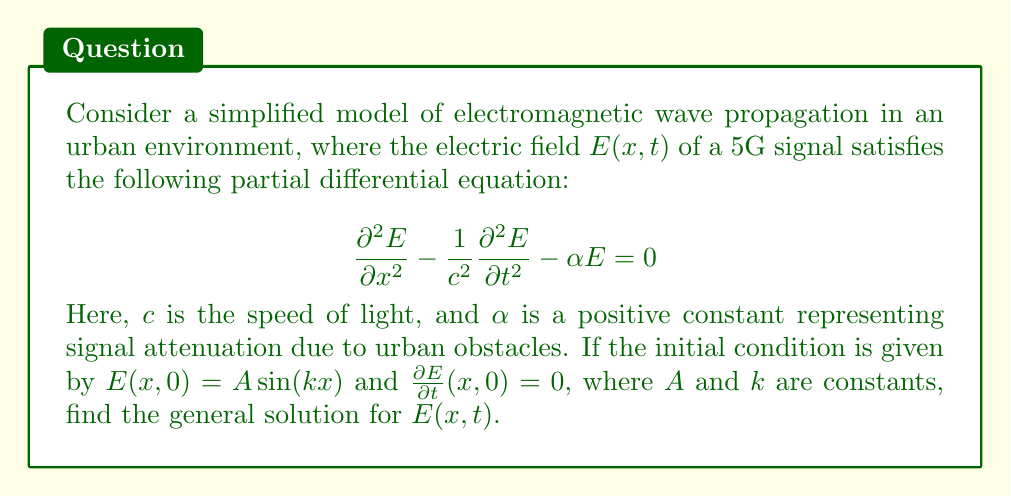Show me your answer to this math problem. Let's solve this problem step by step:

1) The given PDE is a damped wave equation. We can solve it using separation of variables.

2) Assume a solution of the form $E(x,t) = X(x)T(t)$.

3) Substituting this into the PDE:

   $$X''T - \frac{1}{c^2}XT'' - \alpha XT = 0$$

4) Dividing by $XT$:

   $$\frac{X''}{X} - \frac{1}{c^2}\frac{T''}{T} - \alpha = 0$$

5) Let $\frac{X''}{X} = -k^2$ and $\frac{T''}{T} = -\omega^2$. This gives us:

   $$-k^2 + \frac{\omega^2}{c^2} - \alpha = 0$$

6) Solving for $\omega$:

   $$\omega = \pm c\sqrt{k^2 - \alpha}$$

7) The general solutions for $X$ and $T$ are:

   $X(x) = B\sin(kx) + C\cos(kx)$
   $T(t) = D\cos(\omega t) + E\sin(\omega t)$

8) The general solution is thus:

   $$E(x,t) = [B\sin(kx) + C\cos(kx)][D\cos(\omega t) + E\sin(\omega t)]$$

9) Applying the initial conditions:

   $E(x,0) = A\sin(kx)$ implies $C = 0$ and $BD = A$
   $\frac{\partial E}{\partial t}(x,0) = 0$ implies $E = 0$

10) Therefore, the final solution is:

    $$E(x,t) = A\sin(kx)\cos(\omega t)$$

    where $\omega = c\sqrt{k^2 - \alpha}$
Answer: $E(x,t) = A\sin(kx)\cos(c\sqrt{k^2 - \alpha}t)$ 